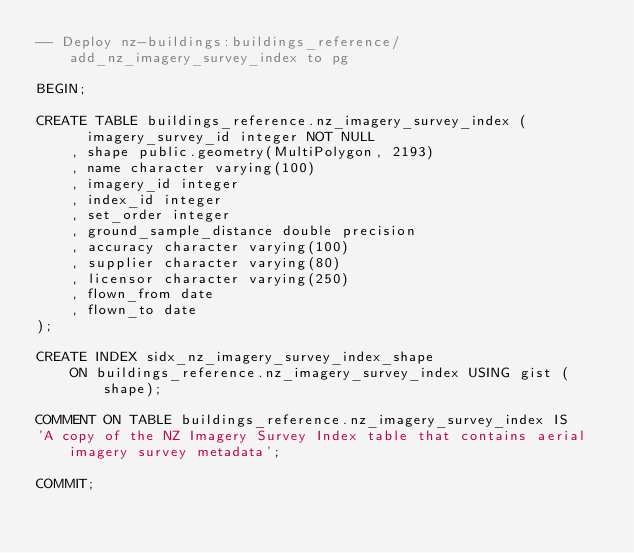<code> <loc_0><loc_0><loc_500><loc_500><_SQL_>-- Deploy nz-buildings:buildings_reference/add_nz_imagery_survey_index to pg

BEGIN;

CREATE TABLE buildings_reference.nz_imagery_survey_index (
      imagery_survey_id integer NOT NULL
    , shape public.geometry(MultiPolygon, 2193)
    , name character varying(100)
    , imagery_id integer
    , index_id integer
    , set_order integer
    , ground_sample_distance double precision
    , accuracy character varying(100)
    , supplier character varying(80)
    , licensor character varying(250)
    , flown_from date
    , flown_to date
);

CREATE INDEX sidx_nz_imagery_survey_index_shape
    ON buildings_reference.nz_imagery_survey_index USING gist (shape);

COMMENT ON TABLE buildings_reference.nz_imagery_survey_index IS
'A copy of the NZ Imagery Survey Index table that contains aerial imagery survey metadata';

COMMIT;
</code> 